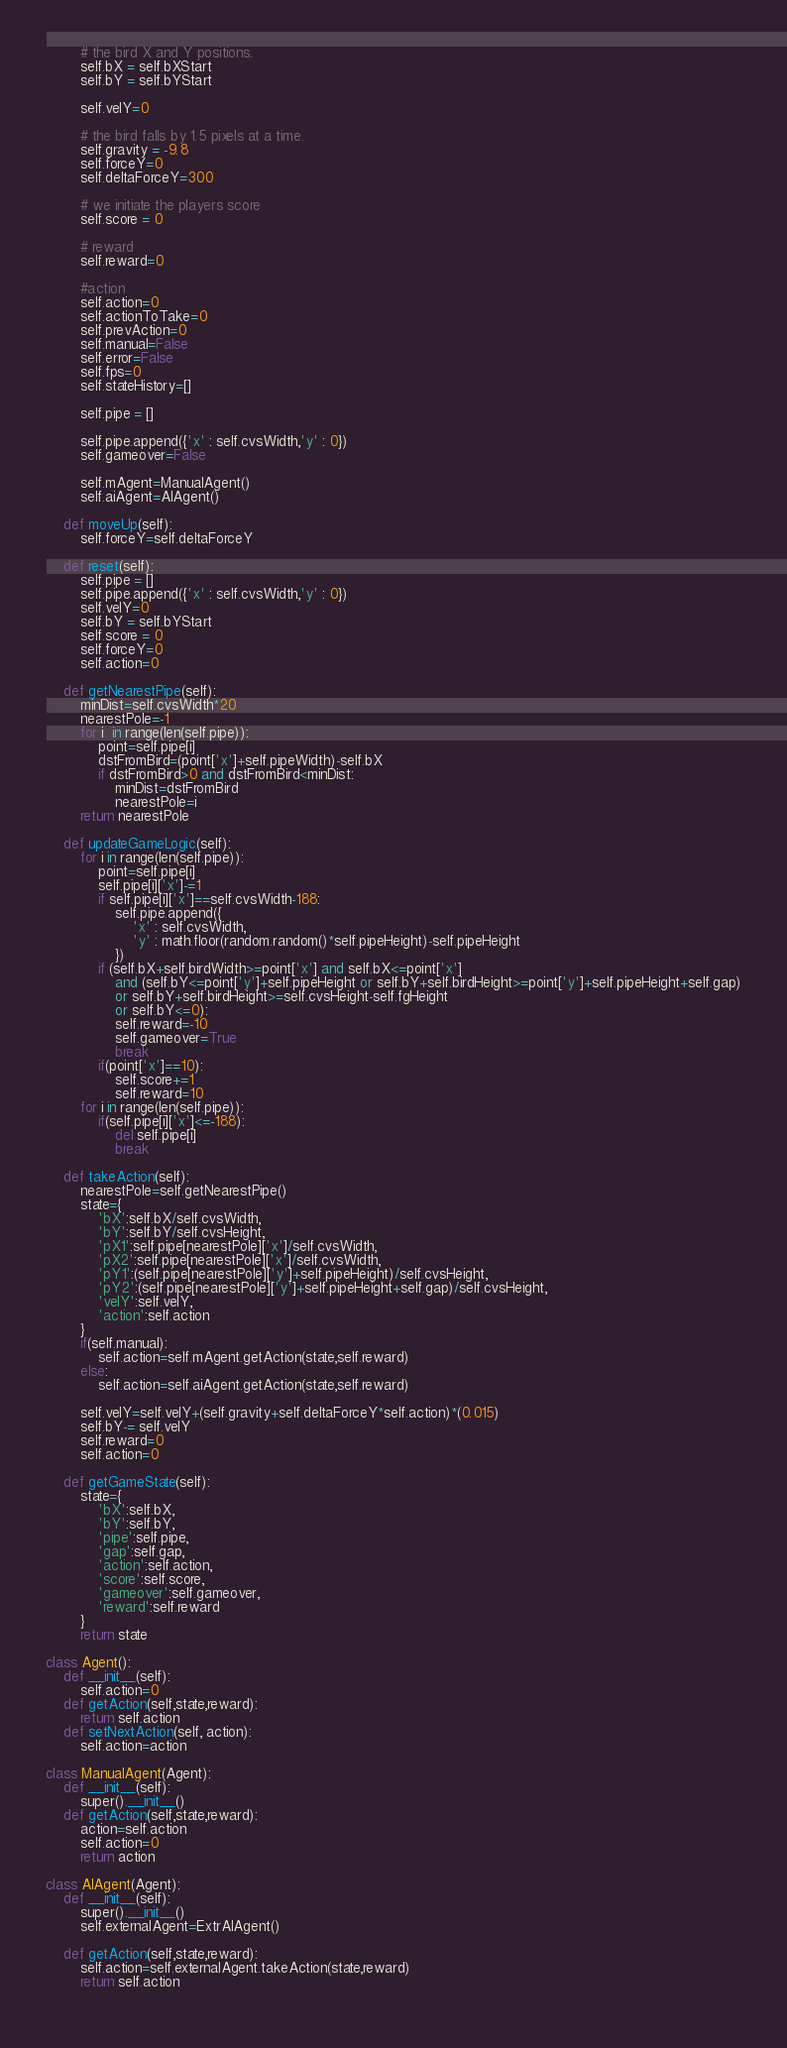Convert code to text. <code><loc_0><loc_0><loc_500><loc_500><_Python_>
        # the bird X and Y positions.
        self.bX = self.bXStart
        self.bY = self.bYStart

        self.velY=0

        # the bird falls by 1.5 pixels at a time.
        self.gravity = -9.8
        self.forceY=0
        self.deltaForceY=300

        # we initiate the players score
        self.score = 0

        # reward
        self.reward=0

        #action
        self.action=0
        self.actionToTake=0
        self.prevAction=0
        self.manual=False
        self.error=False
        self.fps=0
        self.stateHistory=[]

        self.pipe = []

        self.pipe.append({'x' : self.cvsWidth,'y' : 0})
        self.gameover=False

        self.mAgent=ManualAgent()
        self.aiAgent=AIAgent()

    def moveUp(self):
        self.forceY=self.deltaForceY

    def reset(self):
        self.pipe = []
        self.pipe.append({'x' : self.cvsWidth,'y' : 0})
        self.velY=0
        self.bY = self.bYStart
        self.score = 0
        self.forceY=0
        self.action=0

    def getNearestPipe(self):
        minDist=self.cvsWidth*20
        nearestPole=-1
        for i  in range(len(self.pipe)):
            point=self.pipe[i]
            dstFromBird=(point['x']+self.pipeWidth)-self.bX
            if dstFromBird>0 and dstFromBird<minDist:
                minDist=dstFromBird
                nearestPole=i
        return nearestPole
    
    def updateGameLogic(self):
        for i in range(len(self.pipe)):
            point=self.pipe[i]
            self.pipe[i]['x']-=1
            if self.pipe[i]['x']==self.cvsWidth-188:
                self.pipe.append({
                    'x' : self.cvsWidth,
                    'y' : math.floor(random.random()*self.pipeHeight)-self.pipeHeight
                })
            if (self.bX+self.birdWidth>=point['x'] and self.bX<=point['x'] 
                and (self.bY<=point['y']+self.pipeHeight or self.bY+self.birdHeight>=point['y']+self.pipeHeight+self.gap)
                or self.bY+self.birdHeight>=self.cvsHeight-self.fgHeight
                or self.bY<=0):
                self.reward=-10
                self.gameover=True
                break
            if(point['x']==10):
                self.score+=1
                self.reward=10
        for i in range(len(self.pipe)):
            if(self.pipe[i]['x']<=-188):
                del self.pipe[i]
                break
    
    def takeAction(self):
        nearestPole=self.getNearestPipe()
        state={
            'bX':self.bX/self.cvsWidth,
            'bY':self.bY/self.cvsHeight,
            'pX1':self.pipe[nearestPole]['x']/self.cvsWidth,
            'pX2':self.pipe[nearestPole]['x']/self.cvsWidth,
            'pY1':(self.pipe[nearestPole]['y']+self.pipeHeight)/self.cvsHeight,
            'pY2':(self.pipe[nearestPole]['y']+self.pipeHeight+self.gap)/self.cvsHeight,
            'velY':self.velY,
            'action':self.action
        }
        if(self.manual):
            self.action=self.mAgent.getAction(state,self.reward)
        else:
            self.action=self.aiAgent.getAction(state,self.reward)
        
        self.velY=self.velY+(self.gravity+self.deltaForceY*self.action)*(0.015)
        self.bY-= self.velY
        self.reward=0
        self.action=0

    def getGameState(self):
        state={
            'bX':self.bX,
            'bY':self.bY,
            'pipe':self.pipe,
            'gap':self.gap,
            'action':self.action,
            'score':self.score,
            'gameover':self.gameover,
            'reward':self.reward
        }
        return state
        
class Agent():
    def __init__(self):
        self.action=0
    def getAction(self,state,reward):
        return self.action
    def setNextAction(self, action):
        self.action=action

class ManualAgent(Agent):
    def __init__(self):
        super().__init__()
    def getAction(self,state,reward):
        action=self.action
        self.action=0
        return action
    
class AIAgent(Agent):
    def __init__(self):
        super().__init__()
        self.externalAgent=ExtrAIAgent()
    
    def getAction(self,state,reward):
        self.action=self.externalAgent.takeAction(state,reward)
        return self.action
    </code> 